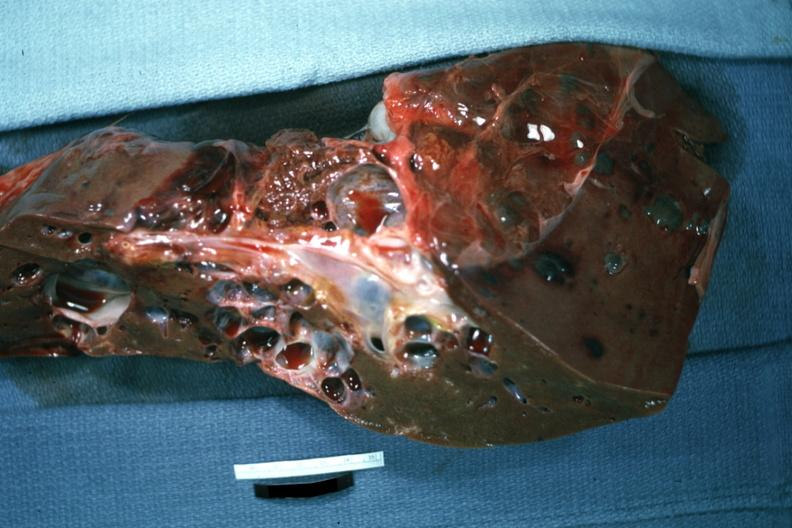s liver present?
Answer the question using a single word or phrase. Yes 